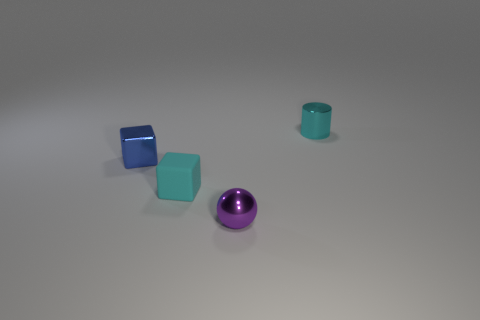Is there a thing that has the same color as the metallic sphere?
Your answer should be very brief. No. There is a blue object that is the same material as the small purple thing; what size is it?
Your answer should be very brief. Small. The matte cube that is the same color as the shiny cylinder is what size?
Ensure brevity in your answer.  Small. How many other things are there of the same size as the blue shiny cube?
Your answer should be very brief. 3. There is a tiny cyan object that is in front of the tiny cyan metal object; what is its material?
Provide a short and direct response. Rubber. There is a tiny cyan object in front of the metal thing left of the tiny cyan thing that is on the left side of the shiny cylinder; what shape is it?
Provide a succinct answer. Cube. Do the purple metal ball and the cylinder have the same size?
Your response must be concise. Yes. What number of objects are shiny spheres or tiny things that are behind the purple object?
Your answer should be compact. 4. How many objects are small things on the left side of the shiny cylinder or things in front of the blue thing?
Provide a succinct answer. 3. There is a tiny blue block; are there any metallic things right of it?
Offer a terse response. Yes. 